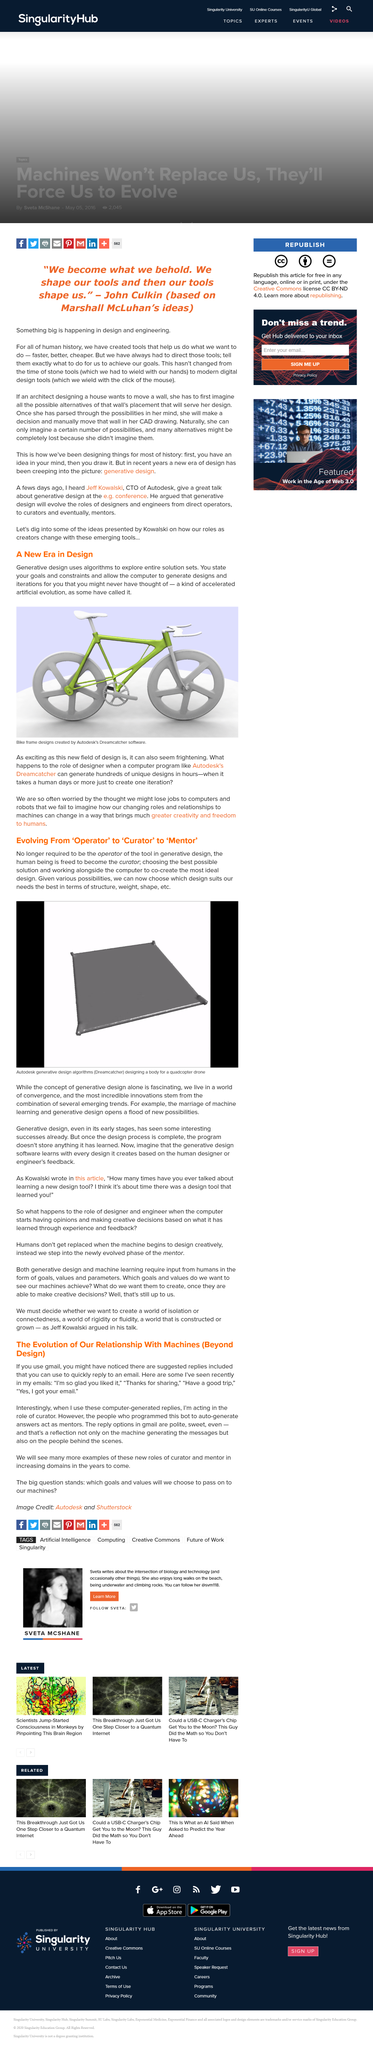Identify some key points in this picture. The title of this section is "A New Era in Design". The human being is no longer required to operate the tool in generative design, as it has been automated. It has been suggested by Gmail that 'I'm so glad you liked' is one of the appropriate responses to a message. The human being is free to be the curator of the tool in generative design, allowing them to exert control over the process and ensure that it meets their desired outcomes. The reply options in Gmail are polite and sweet. 